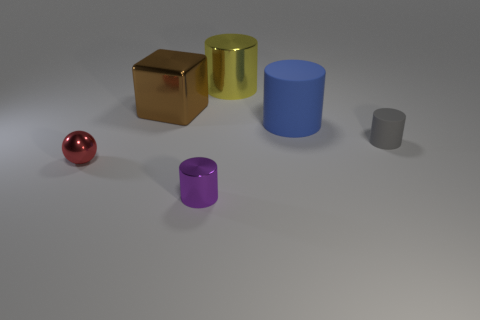The large thing that is on the right side of the small metallic cylinder and behind the blue thing has what shape?
Your answer should be compact. Cylinder. What number of brown objects are either big blocks or small shiny things?
Keep it short and to the point. 1. There is a metal thing that is in front of the small ball; is its size the same as the shiny cylinder behind the shiny ball?
Keep it short and to the point. No. How many things are blue rubber cylinders or purple cylinders?
Provide a succinct answer. 2. Are there any small gray rubber objects that have the same shape as the big blue matte object?
Make the answer very short. Yes. Is the number of large yellow matte cylinders less than the number of tiny purple metal objects?
Your answer should be compact. Yes. Is the purple metallic thing the same shape as the big yellow object?
Offer a very short reply. Yes. How many objects are large brown metal blocks or big objects on the left side of the small purple object?
Offer a very short reply. 1. What number of yellow shiny things are there?
Your response must be concise. 1. Is there a purple thing that has the same size as the gray matte thing?
Offer a very short reply. Yes. 